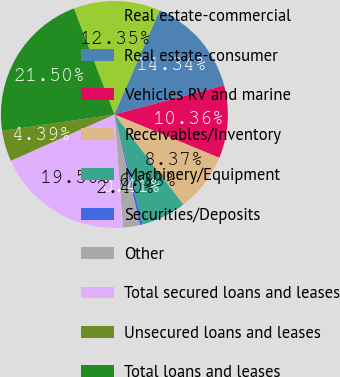<chart> <loc_0><loc_0><loc_500><loc_500><pie_chart><fcel>Real estate-commercial<fcel>Real estate-consumer<fcel>Vehicles RV and marine<fcel>Receivables/Inventory<fcel>Machinery/Equipment<fcel>Securities/Deposits<fcel>Other<fcel>Total secured loans and leases<fcel>Unsecured loans and leases<fcel>Total loans and leases<nl><fcel>12.35%<fcel>14.34%<fcel>10.36%<fcel>8.37%<fcel>6.38%<fcel>0.41%<fcel>2.4%<fcel>19.5%<fcel>4.39%<fcel>21.5%<nl></chart> 